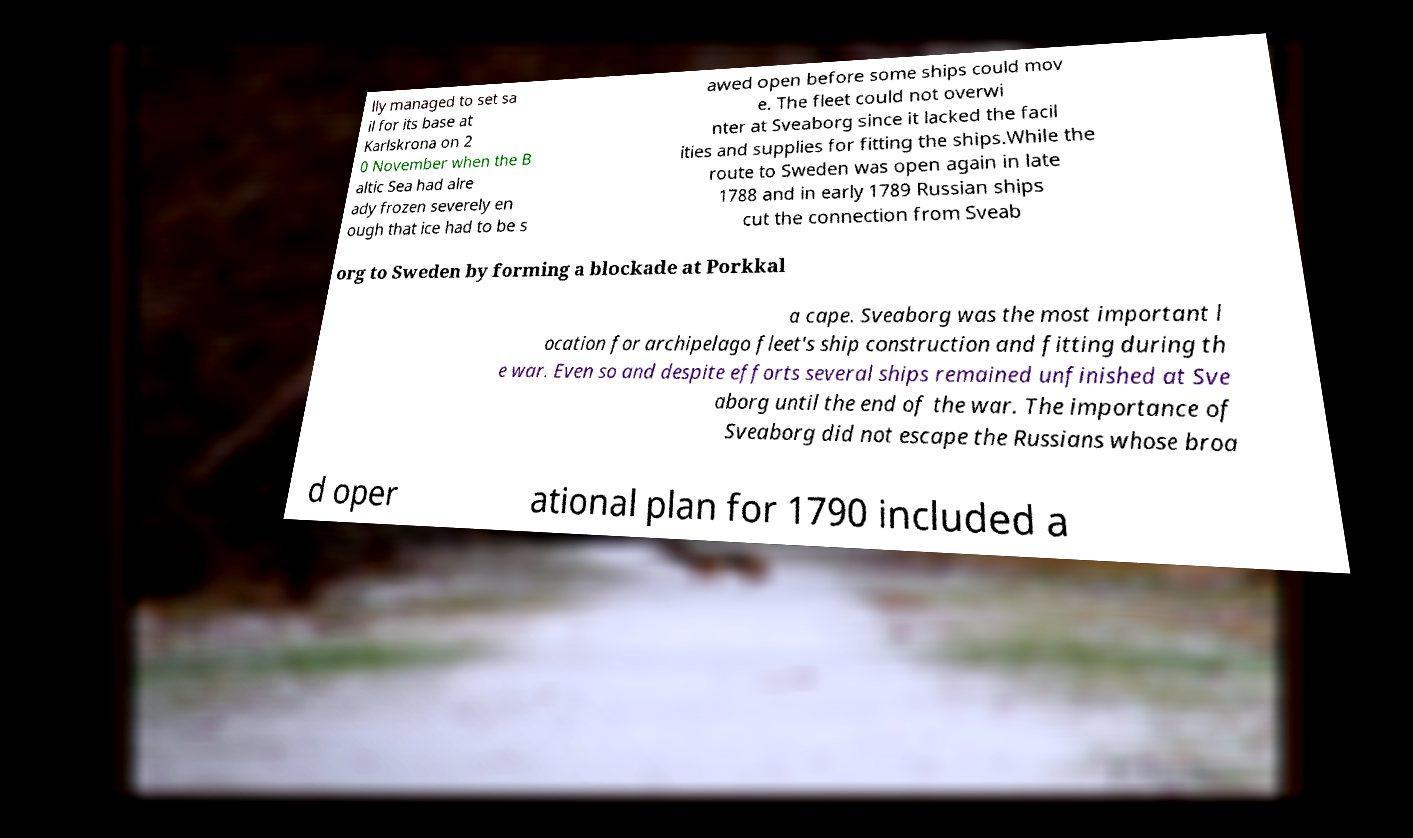Can you accurately transcribe the text from the provided image for me? lly managed to set sa il for its base at Karlskrona on 2 0 November when the B altic Sea had alre ady frozen severely en ough that ice had to be s awed open before some ships could mov e. The fleet could not overwi nter at Sveaborg since it lacked the facil ities and supplies for fitting the ships.While the route to Sweden was open again in late 1788 and in early 1789 Russian ships cut the connection from Sveab org to Sweden by forming a blockade at Porkkal a cape. Sveaborg was the most important l ocation for archipelago fleet's ship construction and fitting during th e war. Even so and despite efforts several ships remained unfinished at Sve aborg until the end of the war. The importance of Sveaborg did not escape the Russians whose broa d oper ational plan for 1790 included a 